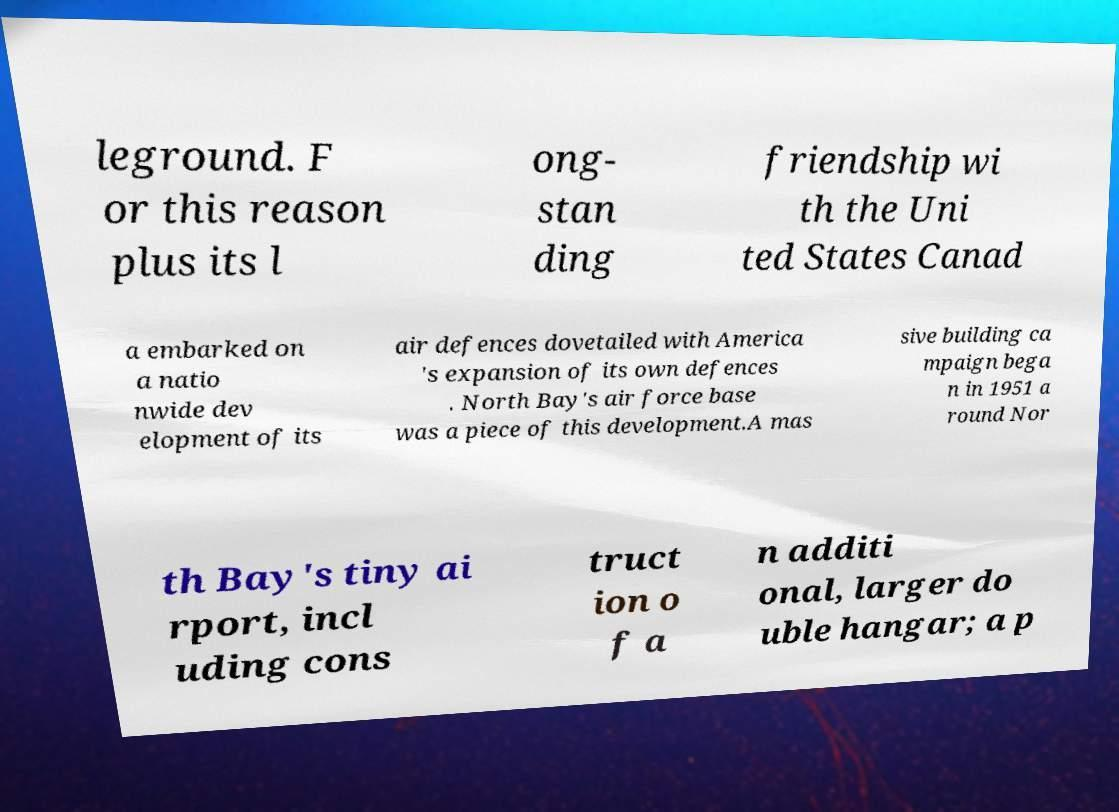What messages or text are displayed in this image? I need them in a readable, typed format. leground. F or this reason plus its l ong- stan ding friendship wi th the Uni ted States Canad a embarked on a natio nwide dev elopment of its air defences dovetailed with America 's expansion of its own defences . North Bay's air force base was a piece of this development.A mas sive building ca mpaign bega n in 1951 a round Nor th Bay's tiny ai rport, incl uding cons truct ion o f a n additi onal, larger do uble hangar; a p 